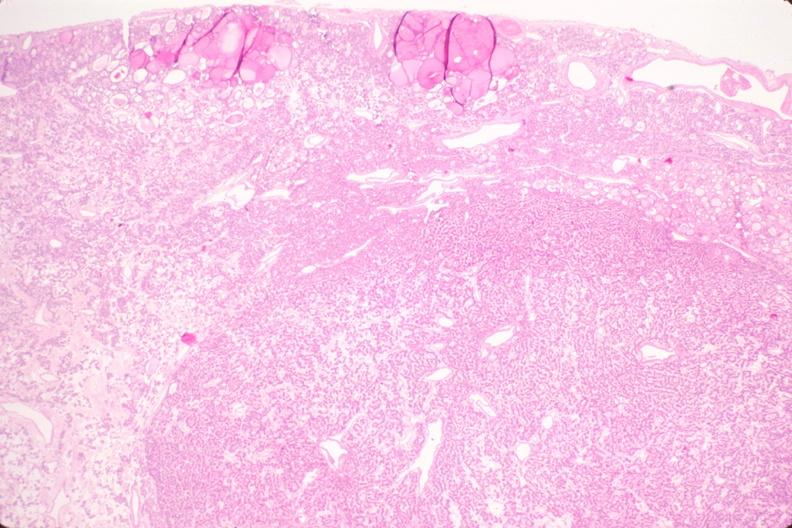s endocrine present?
Answer the question using a single word or phrase. Yes 